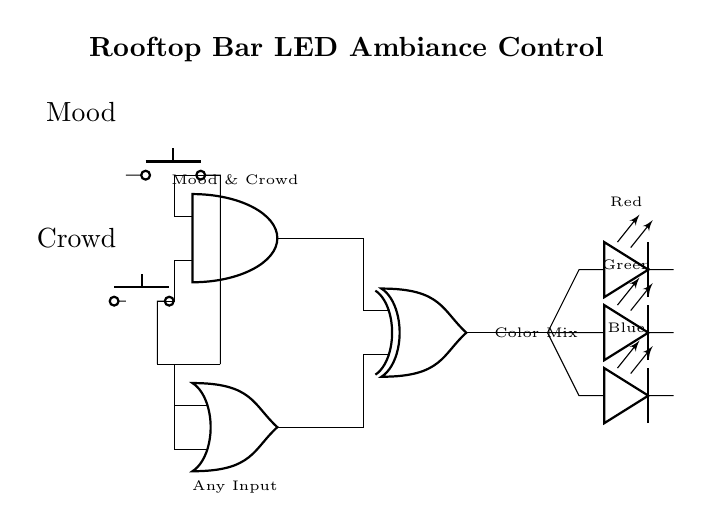What are the input components in the circuit? The input components are the two push buttons labeled "Mood" and "Crowd," which are used to control the logic conditions for the LED output.
Answer: Push buttons How many output LEDs are there? The circuit has three output LEDs, representing the colors Red, Green, and Blue, which are used to create different ambiance settings.
Answer: Three Which logic gate combines the "Mood" and "Crowd" inputs? The AND gate combines the "Mood" and "Crowd" inputs to determine if both conditions are met before affecting the output.
Answer: AND gate What type of logic gate outputs a mixed color? The XOR gate outputs the mixed color based on the inputs from the previous gates, adding complexity to the color output based on the combination of inputs.
Answer: XOR gate What is the function of the OR gate in this circuit? The OR gate allows for any input from either the "Mood" or "Crowd" buttons to influence the output, thereby broadening the conditions that can change the LED colors.
Answer: Any Input How do the inputs affect the output LEDs? The combination of inputs from the push buttons (through the AND and OR gates) influences the XOR gate, which then determines which LEDs are on, thus affecting the color output based on the input state.
Answer: Color Mix 